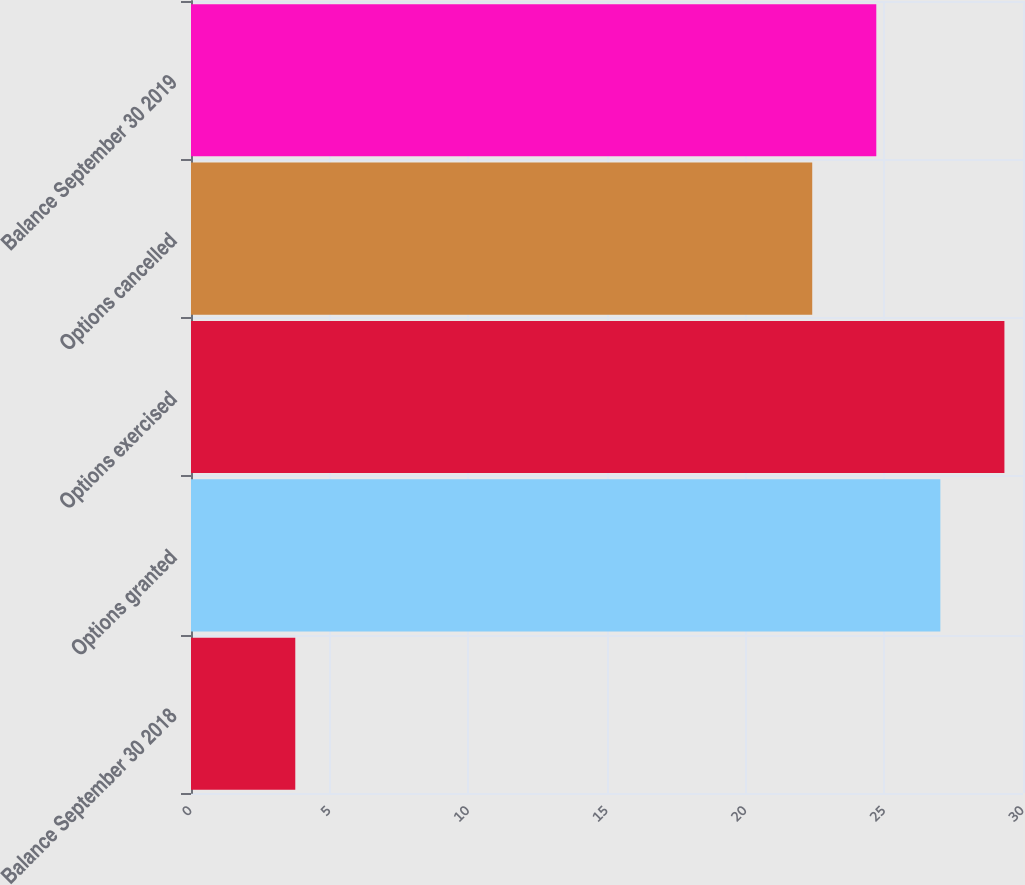<chart> <loc_0><loc_0><loc_500><loc_500><bar_chart><fcel>Balance September 30 2018<fcel>Options granted<fcel>Options exercised<fcel>Options cancelled<fcel>Balance September 30 2019<nl><fcel>3.76<fcel>27.02<fcel>29.33<fcel>22.4<fcel>24.71<nl></chart> 